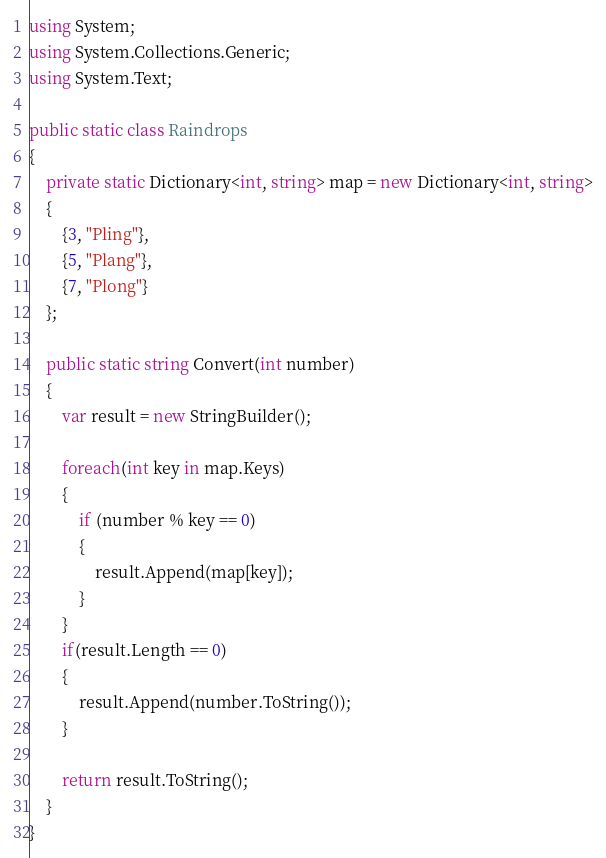Convert code to text. <code><loc_0><loc_0><loc_500><loc_500><_C#_>using System;
using System.Collections.Generic;
using System.Text;

public static class Raindrops
{
    private static Dictionary<int, string> map = new Dictionary<int, string>
    {
        {3, "Pling"},
        {5, "Plang"},
        {7, "Plong"}
    };

    public static string Convert(int number)
    {
        var result = new StringBuilder();

        foreach(int key in map.Keys)
        {
            if (number % key == 0)
            {
                result.Append(map[key]);
            }
        }
        if(result.Length == 0)
        {
            result.Append(number.ToString());
        }

        return result.ToString();
    }
}</code> 